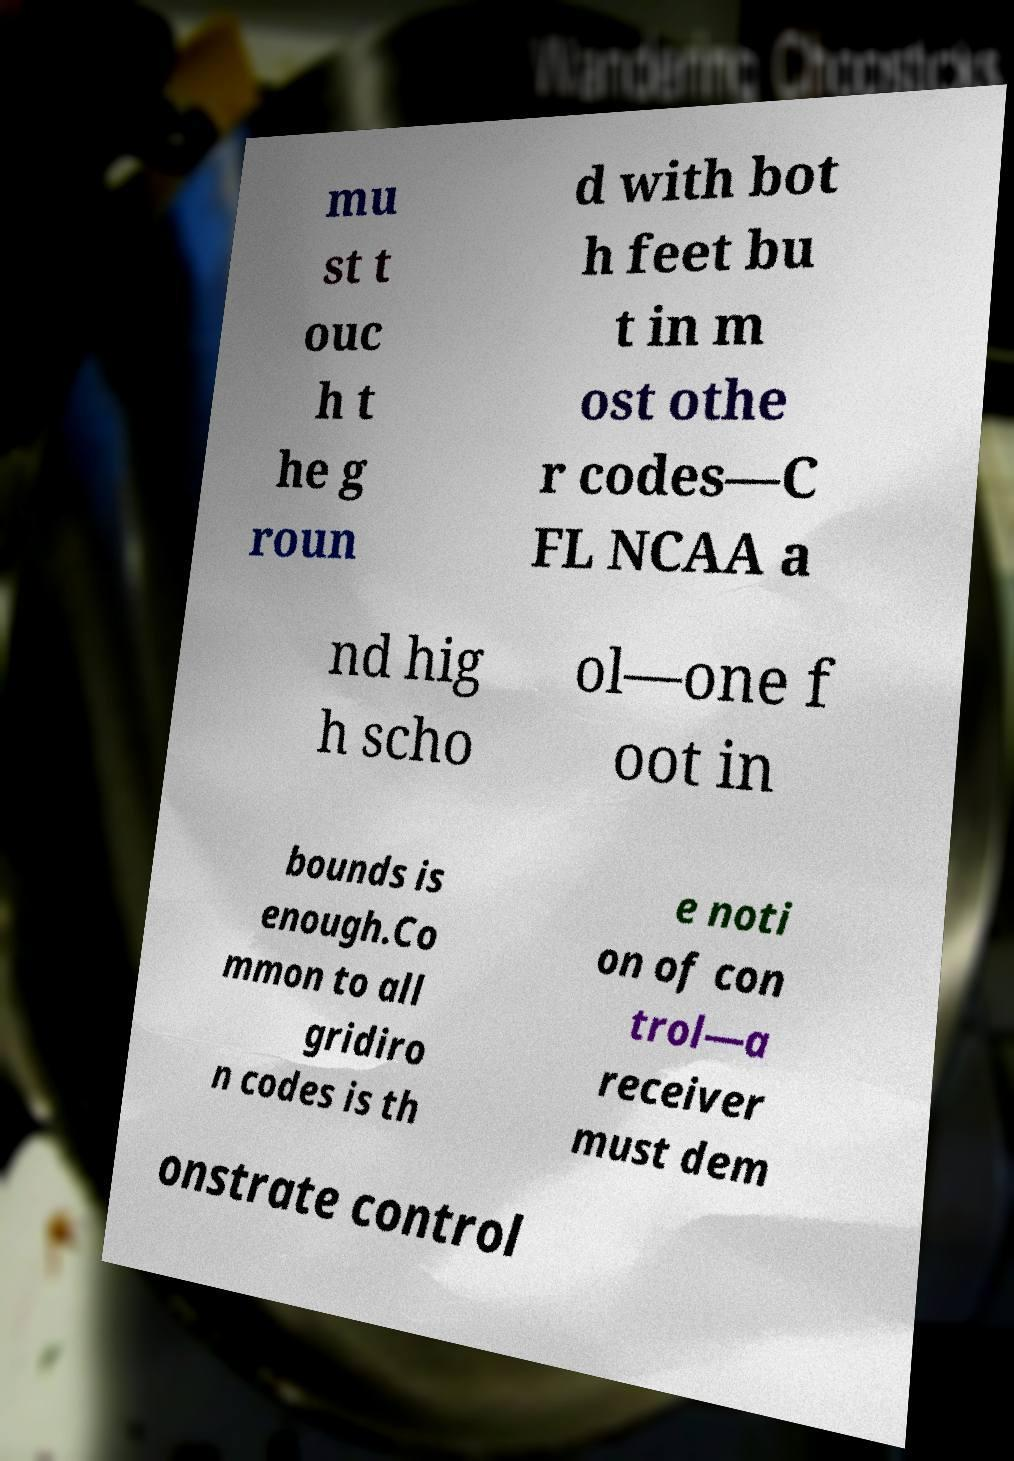For documentation purposes, I need the text within this image transcribed. Could you provide that? mu st t ouc h t he g roun d with bot h feet bu t in m ost othe r codes—C FL NCAA a nd hig h scho ol—one f oot in bounds is enough.Co mmon to all gridiro n codes is th e noti on of con trol—a receiver must dem onstrate control 